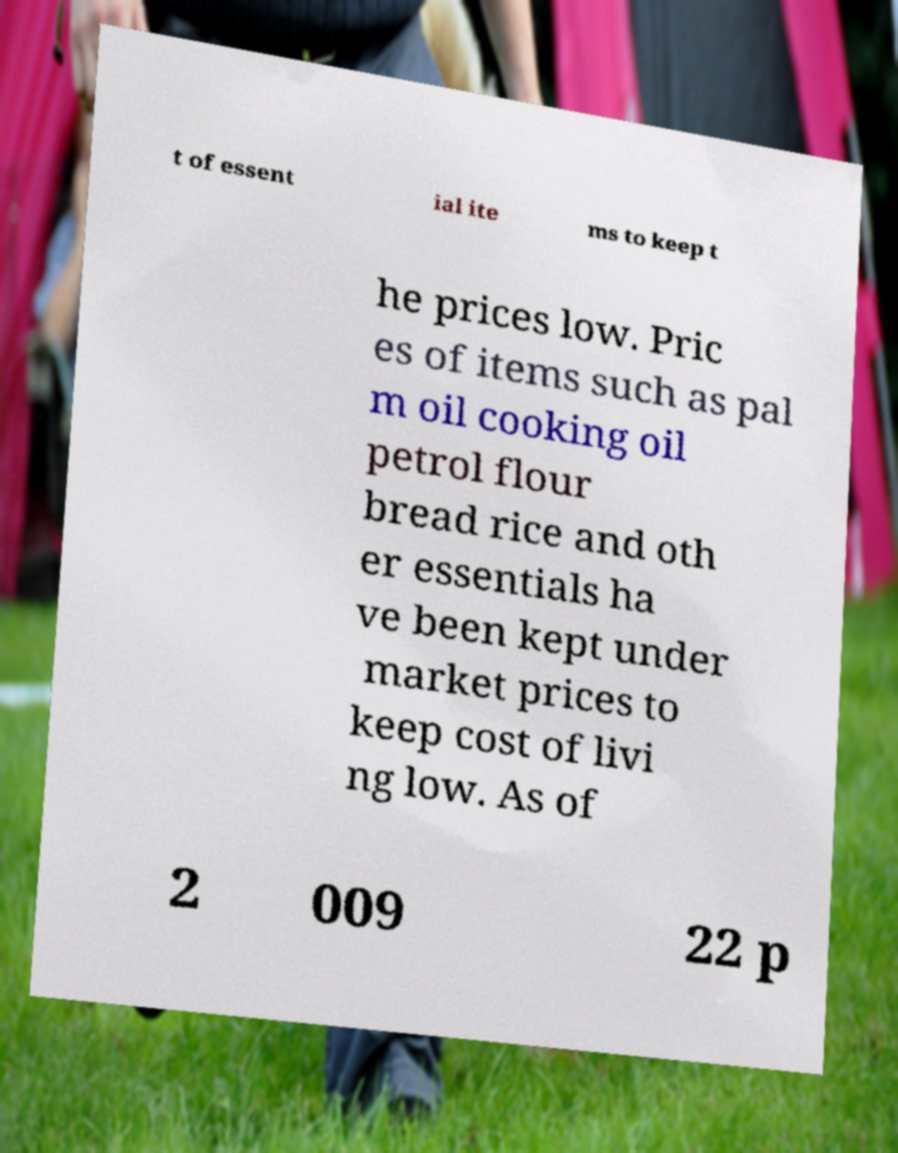There's text embedded in this image that I need extracted. Can you transcribe it verbatim? t of essent ial ite ms to keep t he prices low. Pric es of items such as pal m oil cooking oil petrol flour bread rice and oth er essentials ha ve been kept under market prices to keep cost of livi ng low. As of 2 009 22 p 